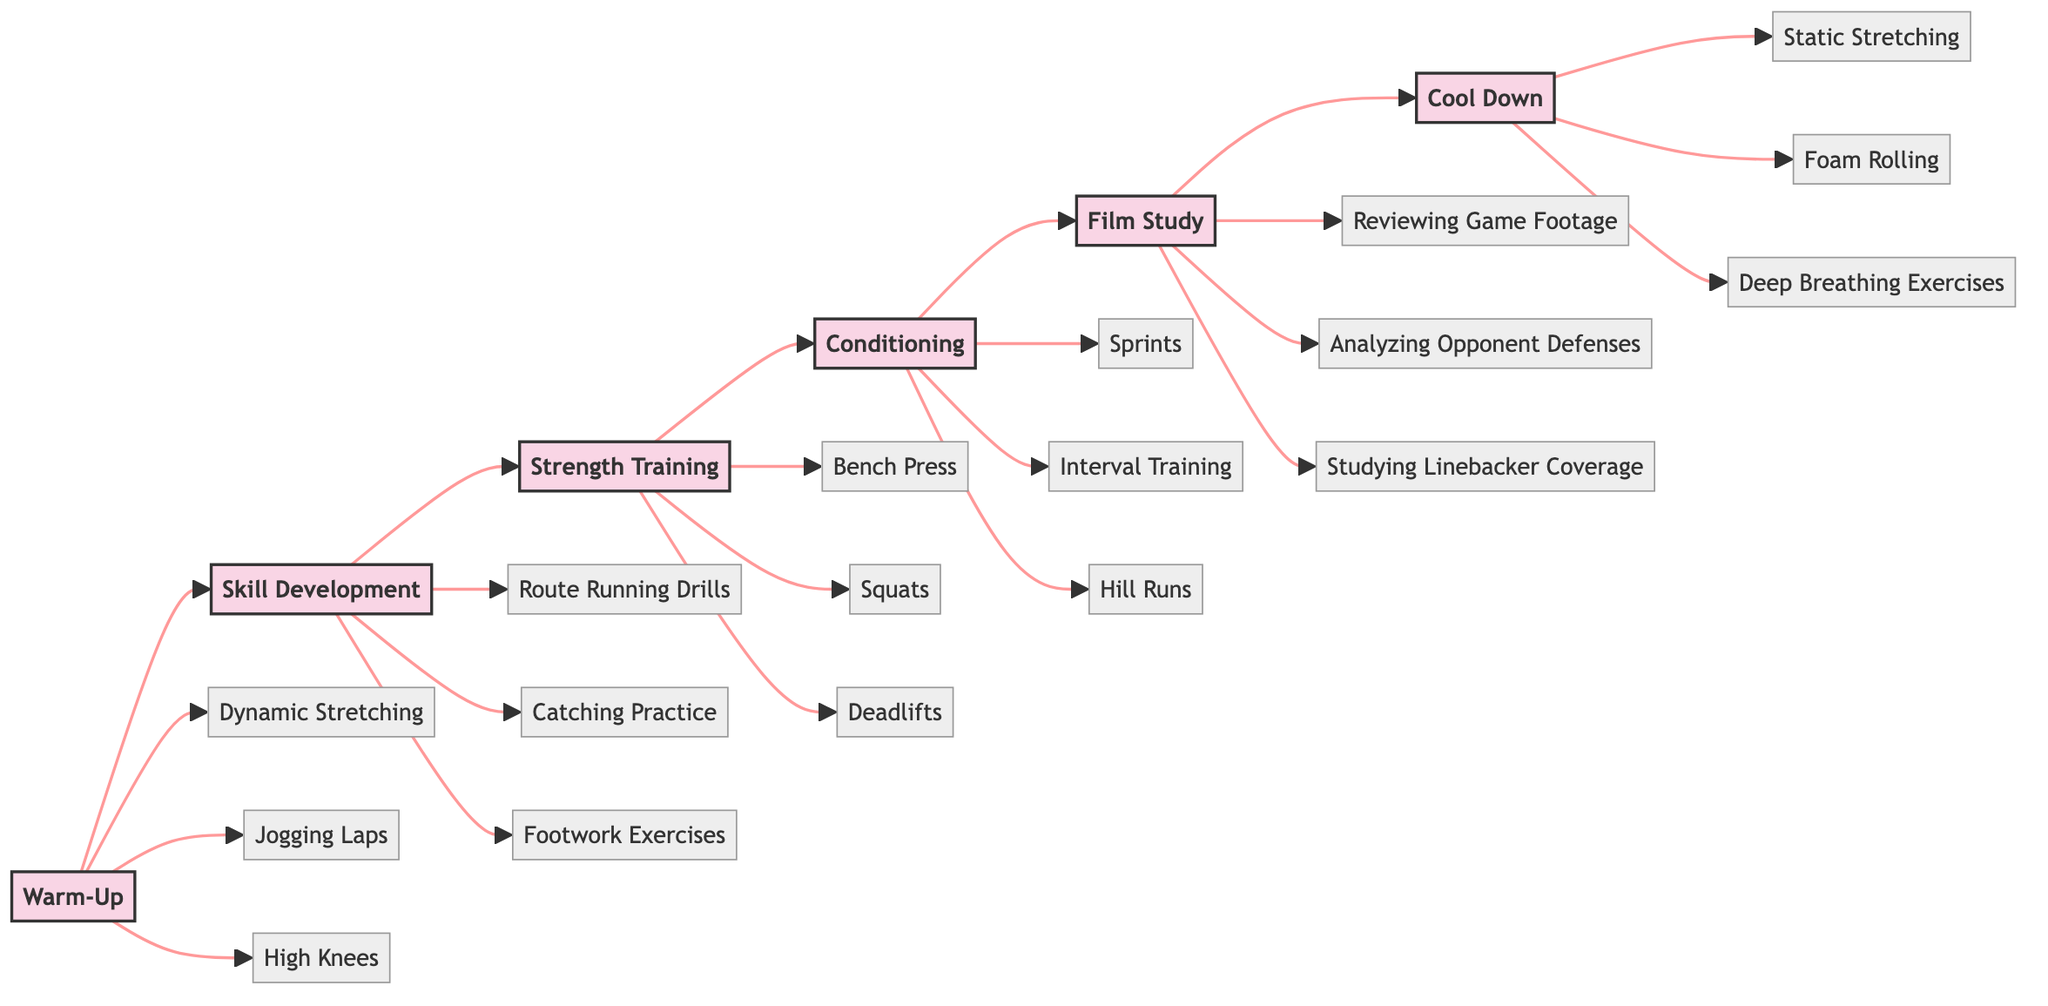What are the elements involved in the Warm-Up stage? The Warm-Up stage includes several elements which can be found by looking at the node connected to Warm-Up, namely the elements listed directly beneath it: Dynamic Stretching, Jogging Laps, High Knees, Butt Kicks, Torso Twists, and Arm Circles.
Answer: Dynamic Stretching, Jogging Laps, High Knees, Butt Kicks, Torso Twists, Arm Circles How many stages are listed in the training routine? To find the total number of stages, I look at the distinct stages presented in the flowchart: Warm-Up, Skill Development, Strength Training, Conditioning, Film Study, and Cool Down, which totals to six stages.
Answer: 6 Which stage comes directly after Skill Development? I can determine the sequence of stages by following the arrows in the flowchart; the arrow that follows Skill Development leads to Strength Training, thus indicating that it comes directly after.
Answer: Strength Training What is the last activity in the Cool Down stage? The Cool Down stage consists of several elements, and the last element listed is Deep Breathing Exercises. I identify this by examining the elements that branch from the Cool Down stage node.
Answer: Deep Breathing Exercises What two stages feature activities focusing on performance review? I see that Film Study is explicitly focused on analyzing performance and includes elements like Reviewing Game Footage and Personal Performance Review. Additionally, the last stage, Cool Down, includes Hydration and Nutrition, which indirectly assists in recovery and performance. However, only Film Study is specifically about performance review based on its elements.
Answer: Film Study, Cool Down Which conditioning activity is associated with endurance training? In the Conditioning stage, all activities relate to endurance, but the activity that best exemplifies this is Sprints. Looking at the distinct elements in the Conditioning stage, I identify Sprints as a crucial exercise focusing on building endurance.
Answer: Sprints What is a skill development activity that emphasizes agility? By reviewing the Skill Development stage, I see that Footwork Exercises are focused on agility, distinguishing them as a significant activity aimed at enhancing this skill.
Answer: Footwork Exercises 